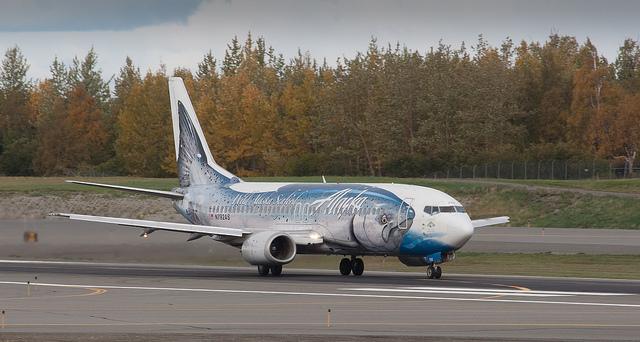Is it fall?
Short answer required. Yes. Where is this plane going?
Concise answer only. Alaska. Is the plane in motion?
Write a very short answer. Yes. 